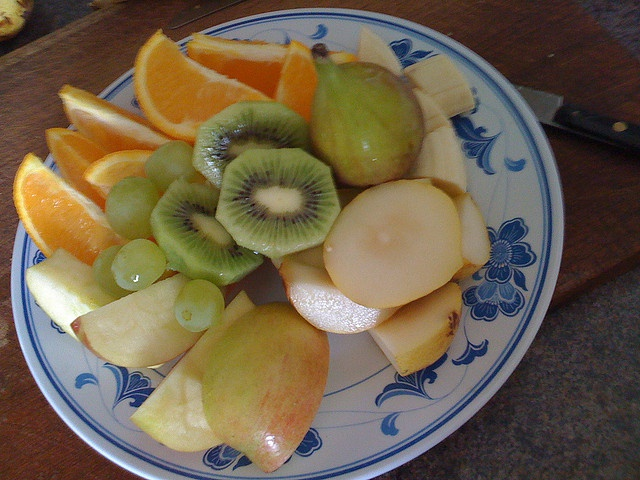Describe the objects in this image and their specific colors. I can see dining table in tan, black, and olive tones, apple in tan, olive, and gray tones, dining table in tan and black tones, apple in tan, olive, and lightgray tones, and orange in tan and olive tones in this image. 